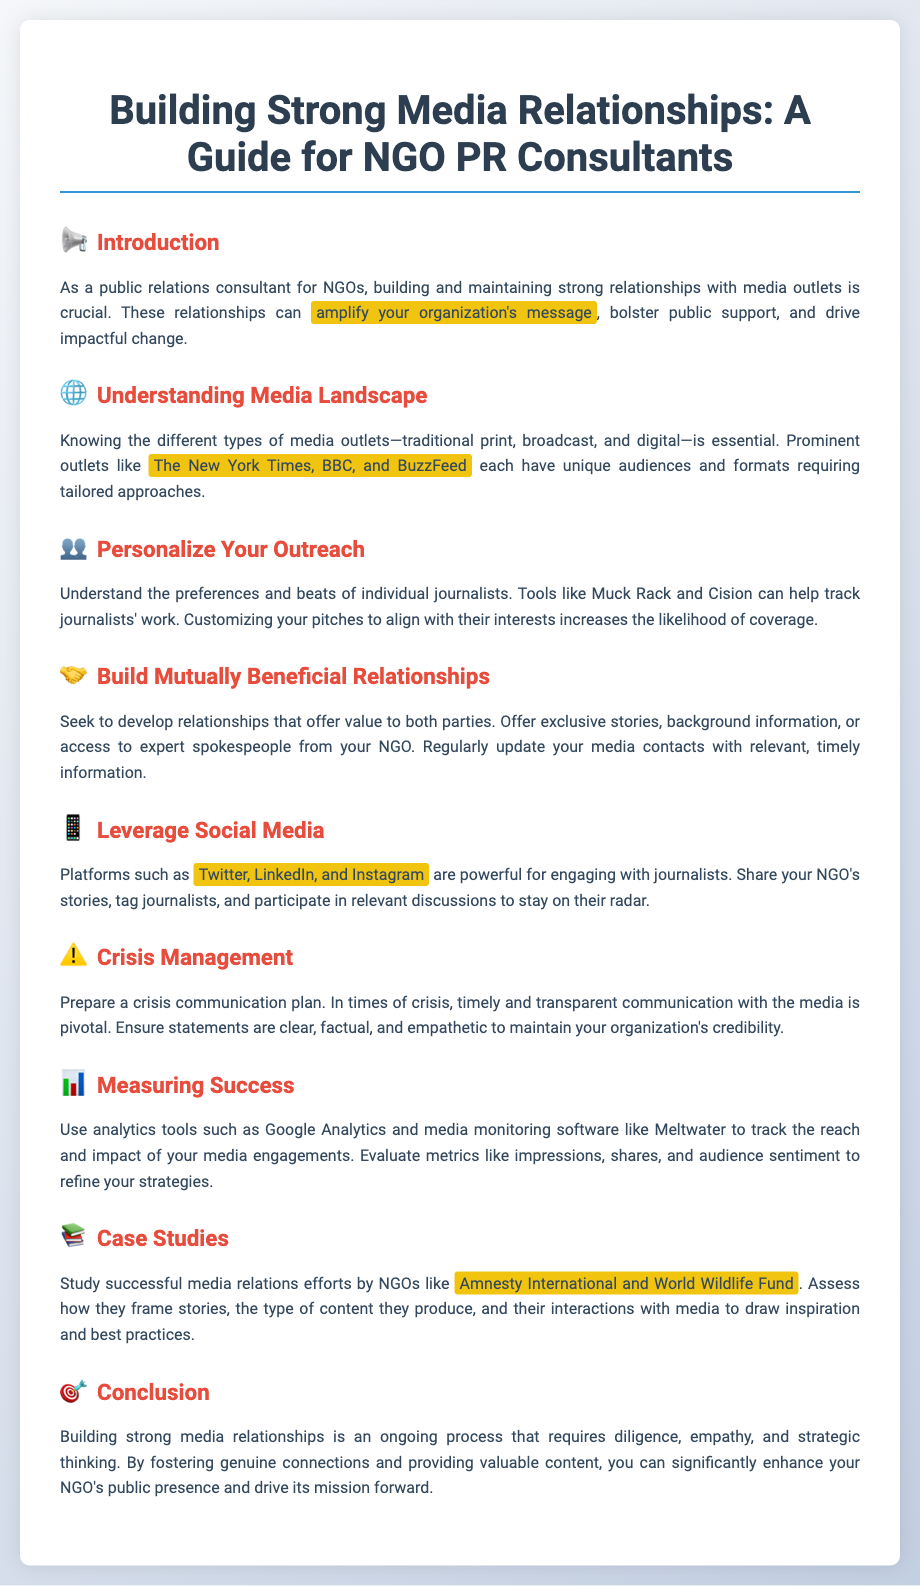What is the title of the poster? The title of the poster is provided at the top of the document.
Answer: Building Strong Media Relationships: A Guide for NGO PR Consultants What is the first section of the poster? The first section of the poster is labeled and covers the introduction.
Answer: Introduction Which platform is mentioned for engaging with journalists? The poster lists several social media platforms for engagement.
Answer: Twitter What type of relationship should NGO PR consultants seek to develop? The document specifies the desired nature of relationships between NGOs and media.
Answer: Mutually Beneficial Relationships What is one tool mentioned for tracking journalists' work? The poster provides examples of tools that can aid in media outreach.
Answer: Muck Rack How should NGOs communicate during a crisis? The poster emphasizes the importance of communication characteristics in crises.
Answer: Timely and Transparent Communication Which NGO is cited as an example of successful media relations? The document highlights particular NGOs known for effective media strategies.
Answer: Amnesty International What should be used to track media engagements impact? The poster recommends specific tools for evaluating media outreach efforts.
Answer: Google Analytics What color theme is used in the poster? The overall appearance and color scheme used in the document can be discerned from its background and section headings.
Answer: White and Light Blue 